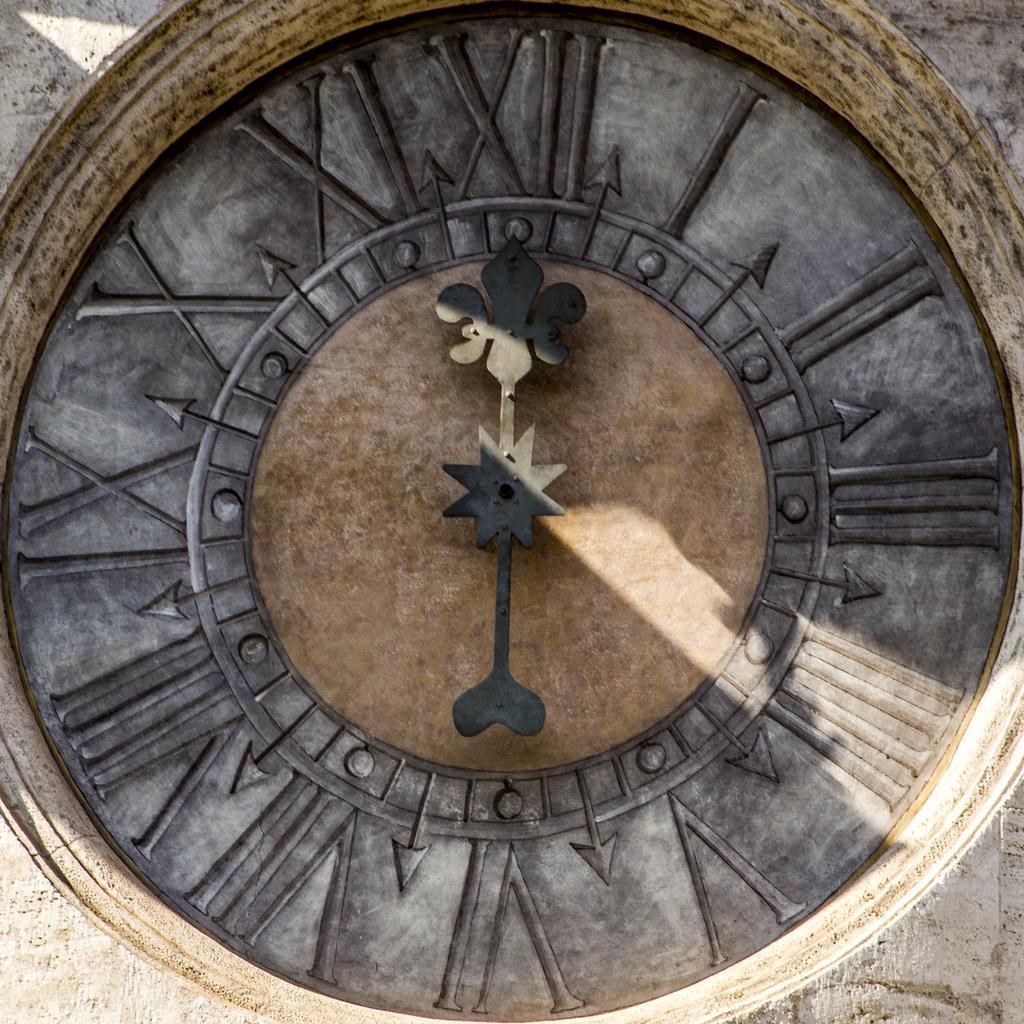How would you summarize this image in a sentence or two? In the middle of this image, there is a clock having an hour hand and minute hand. This clock is attached to a surface. 